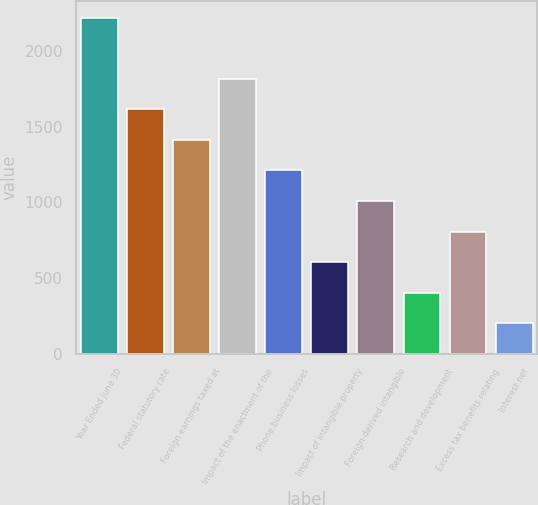<chart> <loc_0><loc_0><loc_500><loc_500><bar_chart><fcel>Year Ended June 30<fcel>Federal statutory rate<fcel>Foreign earnings taxed at<fcel>Impact of the enactment of the<fcel>Phone business losses<fcel>Impact of intangible property<fcel>Foreign-derived intangible<fcel>Research and development<fcel>Excess tax benefits relating<fcel>Interest net<nl><fcel>2219.72<fcel>1614.56<fcel>1412.84<fcel>1816.28<fcel>1211.12<fcel>605.96<fcel>1009.4<fcel>404.24<fcel>807.68<fcel>202.52<nl></chart> 